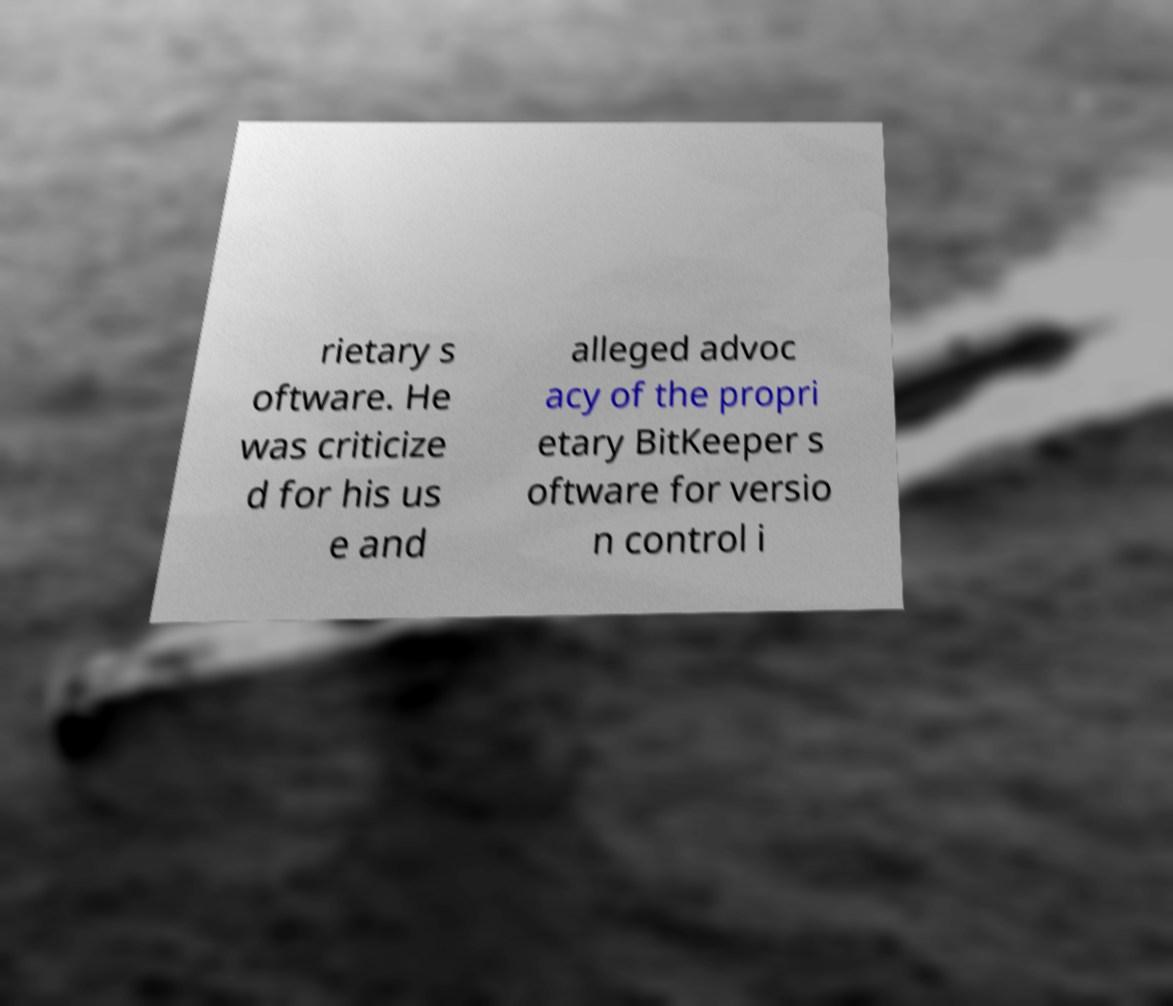For documentation purposes, I need the text within this image transcribed. Could you provide that? rietary s oftware. He was criticize d for his us e and alleged advoc acy of the propri etary BitKeeper s oftware for versio n control i 